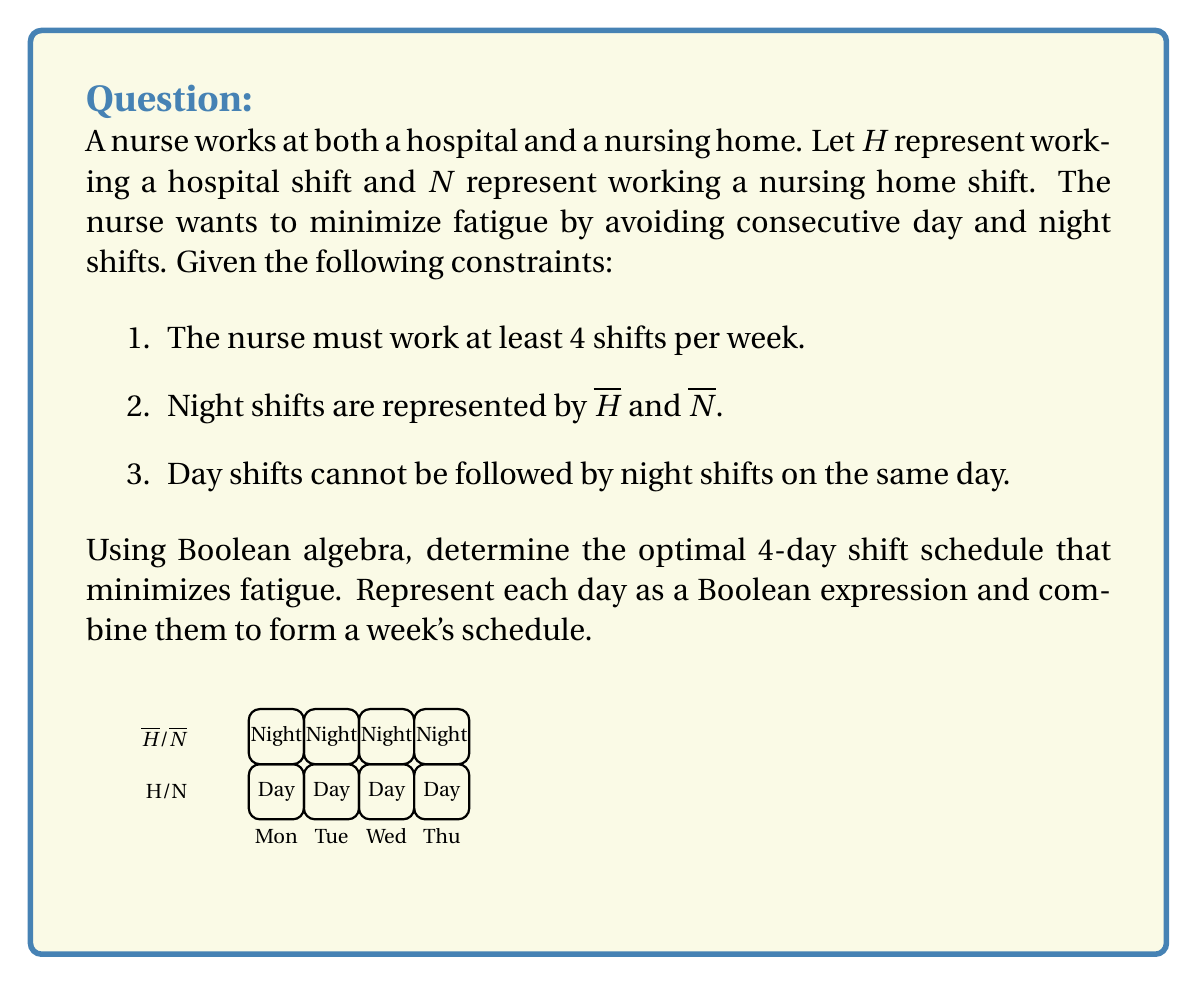Solve this math problem. Let's approach this step-by-step using Boolean algebra:

1) For each day, we have four possible scenarios:
   - Day hospital shift: $H \cdot N$
   - Day nursing home shift: $H \cdot N$
   - Night hospital shift: $\overline{H} \cdot N$
   - Night nursing home shift: $H \cdot \overline{N}$

2) To avoid consecutive day and night shifts, we can use the following pattern:
   Day 1: $(H + N) \cdot (\overline{H} + \overline{N})$
   Day 2: $(\overline{H} + \overline{N}) \cdot (H + N)$
   Day 3: $(H + N) \cdot (\overline{H} + \overline{N})$
   Day 4: $(\overline{H} + \overline{N}) \cdot (H + N)$

3) This pattern ensures that a day shift is followed by a night shift and vice versa, minimizing fatigue.

4) Combining these expressions for a 4-day schedule:
   $$ [(H + N) \cdot (\overline{H} + \overline{N})] \cdot [(\overline{H} + \overline{N}) \cdot (H + N)] \cdot [(H + N) \cdot (\overline{H} + \overline{N})] \cdot [(\overline{H} + \overline{N}) \cdot (H + N)] $$

5) This expression represents all possible combinations that satisfy the constraints.

6) To ensure at least 4 shifts per week, we need to choose one shift per day from this expression.

7) An optimal schedule that minimizes fatigue while meeting all constraints could be:
   Day 1: Day hospital shift $(H \cdot \overline{N})$
   Day 2: Night nursing home shift $(H \cdot \overline{N})$
   Day 3: Day nursing home shift $(\overline{H} \cdot N)$
   Day 4: Night hospital shift $(\overline{H} \cdot N)$

8) This schedule alternates between day and night shifts and between hospital and nursing home, providing variety and minimizing consecutive similar shifts.
Answer: $$(H \cdot \overline{N}) \cdot (H \cdot \overline{N}) \cdot (\overline{H} \cdot N) \cdot (\overline{H} \cdot N)$$ 